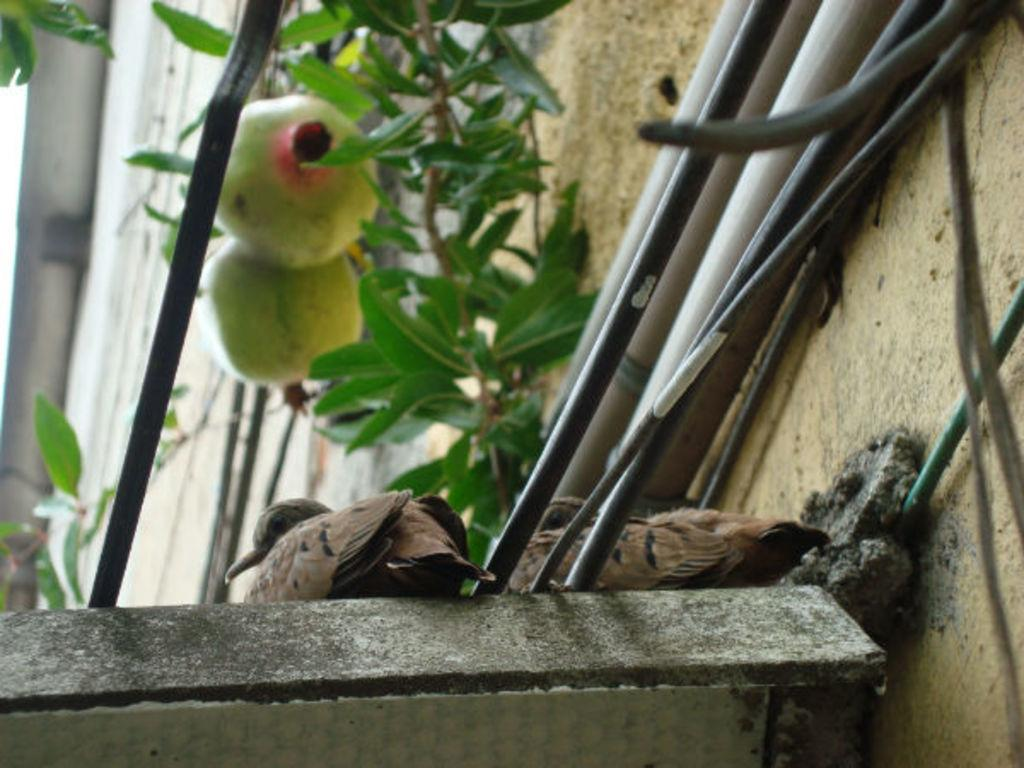What animals are sitting on the shelf in the image? There are birds sitting on a shelf in the image. What can be seen above the shelf on the wall? There are wires above the shelf on the wall. What type of vegetation is present in the image? There is a plant in the image. What is hanging from the plant in the image? The plant has two fruits hanging from it. How long does it take for the pump to crack the minute in the image? There is no pump or minute present in the image, so this question cannot be answered. 